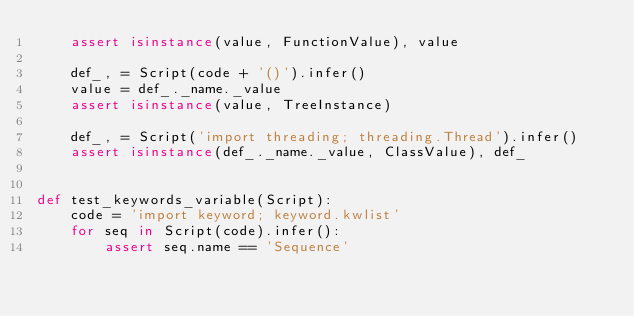Convert code to text. <code><loc_0><loc_0><loc_500><loc_500><_Python_>    assert isinstance(value, FunctionValue), value

    def_, = Script(code + '()').infer()
    value = def_._name._value
    assert isinstance(value, TreeInstance)

    def_, = Script('import threading; threading.Thread').infer()
    assert isinstance(def_._name._value, ClassValue), def_


def test_keywords_variable(Script):
    code = 'import keyword; keyword.kwlist'
    for seq in Script(code).infer():
        assert seq.name == 'Sequence'</code> 